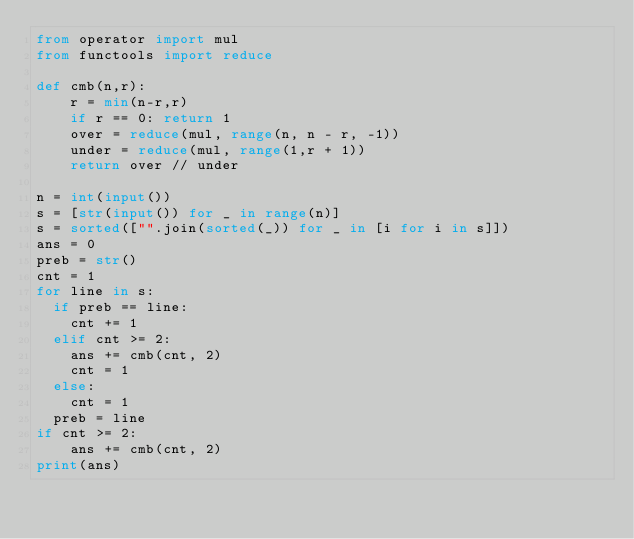Convert code to text. <code><loc_0><loc_0><loc_500><loc_500><_Python_>from operator import mul
from functools import reduce

def cmb(n,r):
    r = min(n-r,r)
    if r == 0: return 1
    over = reduce(mul, range(n, n - r, -1))
    under = reduce(mul, range(1,r + 1))
    return over // under

n = int(input())
s = [str(input()) for _ in range(n)]
s = sorted(["".join(sorted(_)) for _ in [i for i in s]])
ans = 0
preb = str()
cnt = 1
for line in s:
  if preb == line:
    cnt += 1
  elif cnt >= 2:
    ans += cmb(cnt, 2)
    cnt = 1
  else:
    cnt = 1
  preb = line
if cnt >= 2:
    ans += cmb(cnt, 2)
print(ans)</code> 